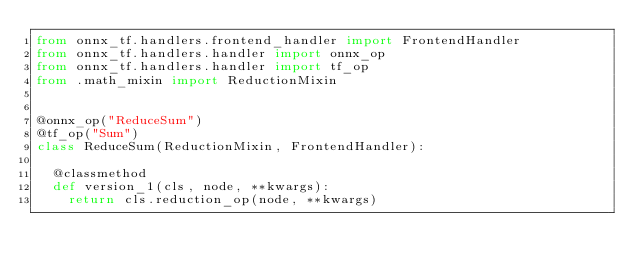Convert code to text. <code><loc_0><loc_0><loc_500><loc_500><_Python_>from onnx_tf.handlers.frontend_handler import FrontendHandler
from onnx_tf.handlers.handler import onnx_op
from onnx_tf.handlers.handler import tf_op
from .math_mixin import ReductionMixin


@onnx_op("ReduceSum")
@tf_op("Sum")
class ReduceSum(ReductionMixin, FrontendHandler):

  @classmethod
  def version_1(cls, node, **kwargs):
    return cls.reduction_op(node, **kwargs)
</code> 